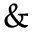Convert formula to latex. <formula><loc_0><loc_0><loc_500><loc_500>\&</formula> 